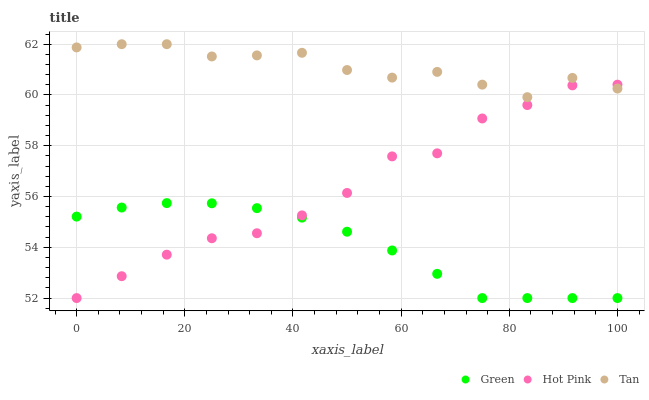Does Green have the minimum area under the curve?
Answer yes or no. Yes. Does Tan have the maximum area under the curve?
Answer yes or no. Yes. Does Hot Pink have the minimum area under the curve?
Answer yes or no. No. Does Hot Pink have the maximum area under the curve?
Answer yes or no. No. Is Green the smoothest?
Answer yes or no. Yes. Is Hot Pink the roughest?
Answer yes or no. Yes. Is Hot Pink the smoothest?
Answer yes or no. No. Is Green the roughest?
Answer yes or no. No. Does Hot Pink have the lowest value?
Answer yes or no. Yes. Does Tan have the highest value?
Answer yes or no. Yes. Does Hot Pink have the highest value?
Answer yes or no. No. Is Green less than Tan?
Answer yes or no. Yes. Is Tan greater than Green?
Answer yes or no. Yes. Does Hot Pink intersect Green?
Answer yes or no. Yes. Is Hot Pink less than Green?
Answer yes or no. No. Is Hot Pink greater than Green?
Answer yes or no. No. Does Green intersect Tan?
Answer yes or no. No. 